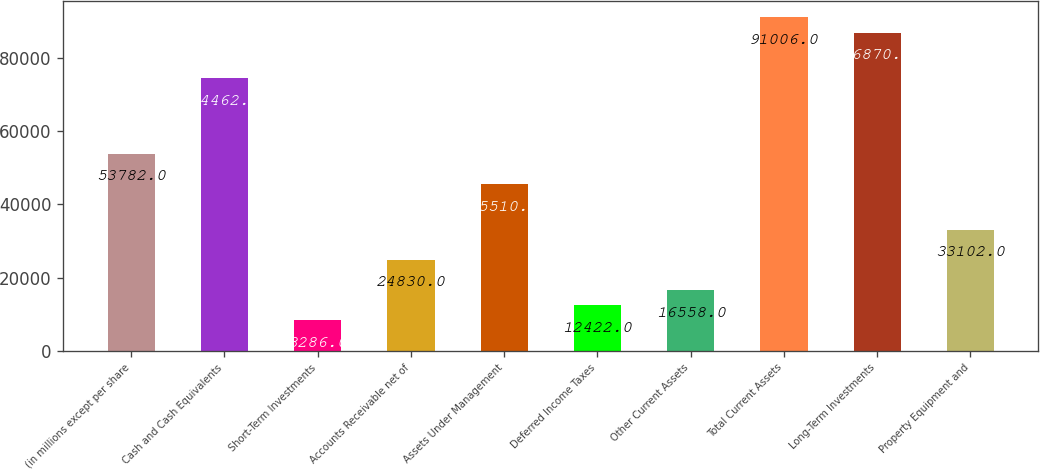Convert chart. <chart><loc_0><loc_0><loc_500><loc_500><bar_chart><fcel>(in millions except per share<fcel>Cash and Cash Equivalents<fcel>Short-Term Investments<fcel>Accounts Receivable net of<fcel>Assets Under Management<fcel>Deferred Income Taxes<fcel>Other Current Assets<fcel>Total Current Assets<fcel>Long-Term Investments<fcel>Property Equipment and<nl><fcel>53782<fcel>74462<fcel>8286<fcel>24830<fcel>45510<fcel>12422<fcel>16558<fcel>91006<fcel>86870<fcel>33102<nl></chart> 